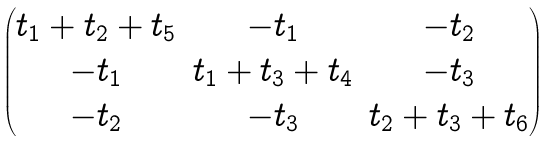Convert formula to latex. <formula><loc_0><loc_0><loc_500><loc_500>\begin{pmatrix} t _ { 1 } + t _ { 2 } + t _ { 5 } & - t _ { 1 } & - t _ { 2 } \\ - t _ { 1 } & t _ { 1 } + t _ { 3 } + t _ { 4 } & - t _ { 3 } \\ - t _ { 2 } & - t _ { 3 } & t _ { 2 } + t _ { 3 } + t _ { 6 } \end{pmatrix}</formula> 